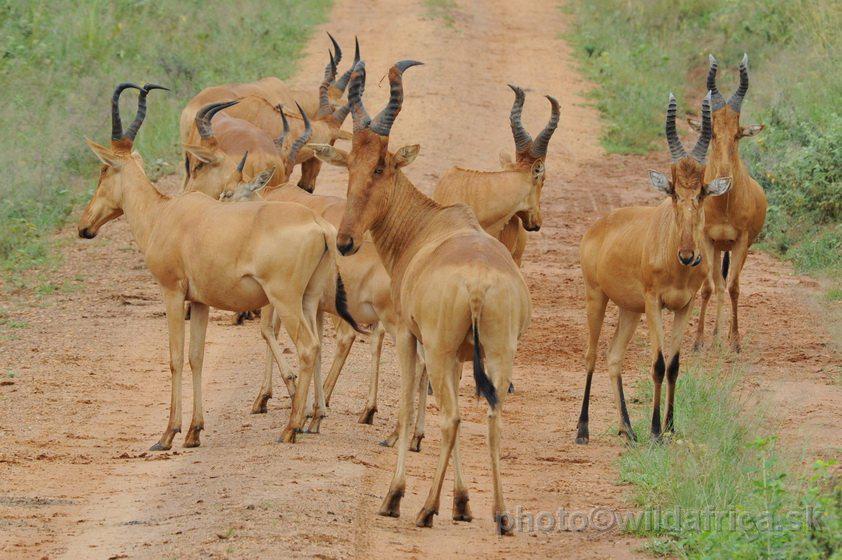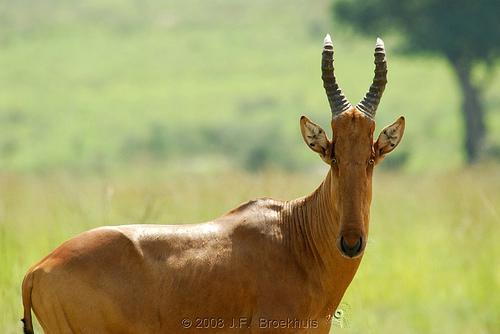The first image is the image on the left, the second image is the image on the right. Examine the images to the left and right. Is the description "At least 7 hartebeests walk down a dirt road." accurate? Answer yes or no. Yes. The first image is the image on the left, the second image is the image on the right. Evaluate the accuracy of this statement regarding the images: "There are only two horned animals standing outside, one in each image.". Is it true? Answer yes or no. No. 